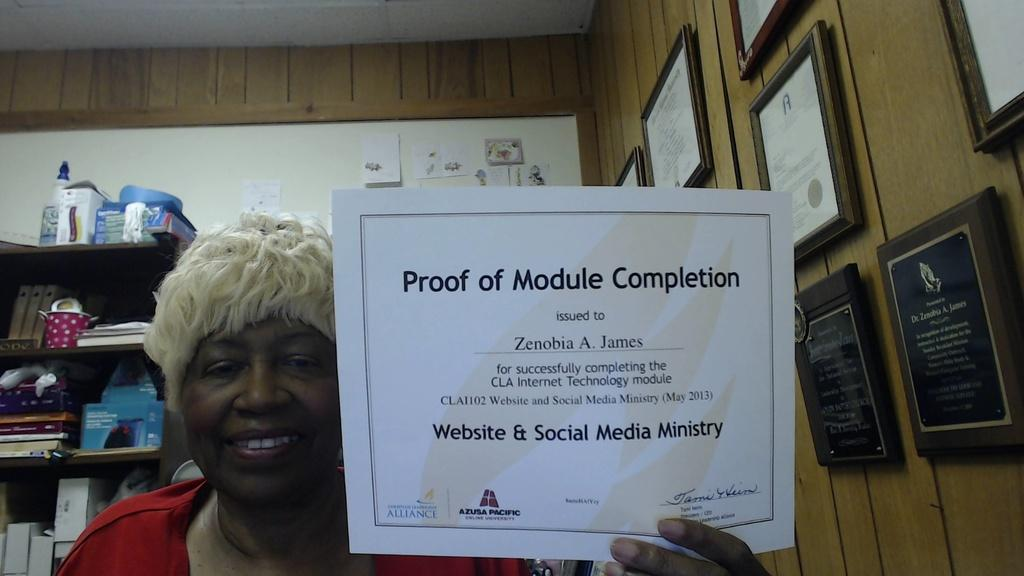<image>
Describe the image concisely. a woman holding up a certificate that says 'proof of module completion' 